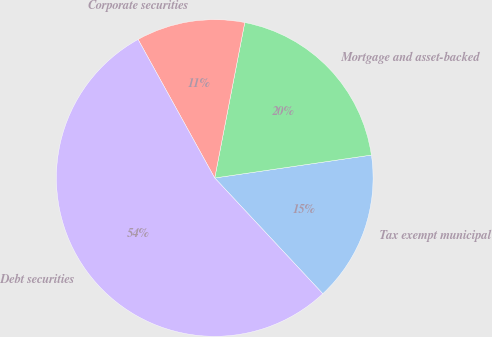<chart> <loc_0><loc_0><loc_500><loc_500><pie_chart><fcel>Tax exempt municipal<fcel>Mortgage and asset-backed<fcel>Corporate securities<fcel>Debt securities<nl><fcel>15.36%<fcel>19.65%<fcel>11.08%<fcel>53.91%<nl></chart> 